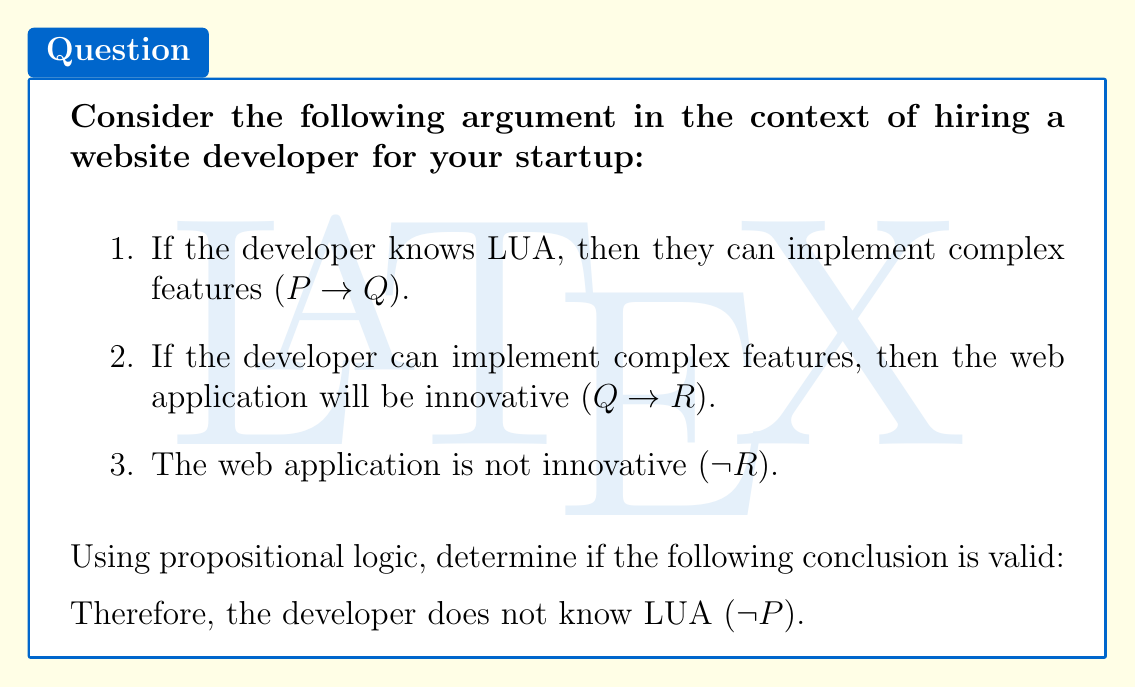Show me your answer to this math problem. To analyze the validity of this argument, we'll use the method of contraposition and modus tollens.

1. Let's start with the given premises:
   P: The developer knows LUA
   Q: The developer can implement complex features
   R: The web application is innovative

   Premises:
   P → Q
   Q → R
   ~R

2. We want to prove ~P (the developer does not know LUA). Let's use contraposition on the first two premises:

   P → Q is equivalent to ~Q → ~P
   Q → R is equivalent to ~R → ~Q

3. Now we have:
   ~R → ~Q
   ~Q → ~P

4. We can combine these using the transitive property of implication:
   If ~R → ~Q and ~Q → ~P, then ~R → ~P

5. We're given ~R as a premise, so we can apply modus ponens:
   ~R (given)
   ~R → ~P (from step 4)
   Therefore, ~P

This demonstrates that the conclusion ~P logically follows from the given premises using valid rules of inference.

The argument can be represented formally as:

$$(P \rightarrow Q) \land (Q \rightarrow R) \land \neg R \vdash \neg P$$

This is a valid argument form known as the law of syllogism combined with modus tollens.
Answer: The conclusion that the developer does not know LUA (~P) is valid based on the given premises and propositional logic rules. 